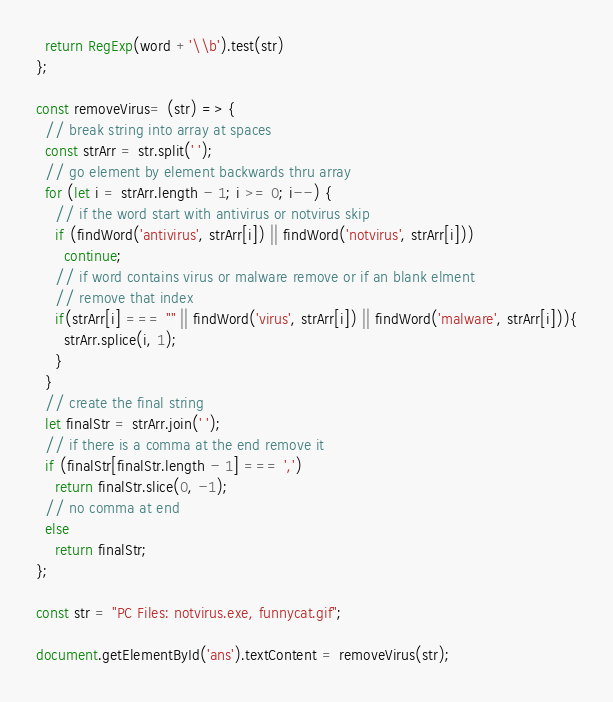<code> <loc_0><loc_0><loc_500><loc_500><_JavaScript_>  return RegExp(word +'\\b').test(str)
};

const removeVirus= (str) => {
  // break string into array at spaces
  const strArr = str.split(' ');
  // go element by element backwards thru array
  for (let i = strArr.length - 1; i >= 0; i--) {
    // if the word start with antivirus or notvirus skip
    if (findWord('antivirus', strArr[i]) || findWord('notvirus', strArr[i]))
      continue;
    // if word contains virus or malware remove or if an blank elment
    // remove that index
    if(strArr[i] === "" || findWord('virus', strArr[i]) || findWord('malware', strArr[i])){
      strArr.splice(i, 1);
    }
  }
  // create the final string
  let finalStr = strArr.join(' ');
  // if there is a comma at the end remove it
  if (finalStr[finalStr.length - 1] === ',')
    return finalStr.slice(0, -1);
  // no comma at end
  else 
    return finalStr;
};

const str = "PC Files: notvirus.exe, funnycat.gif";

document.getElementById('ans').textContent = removeVirus(str);</code> 